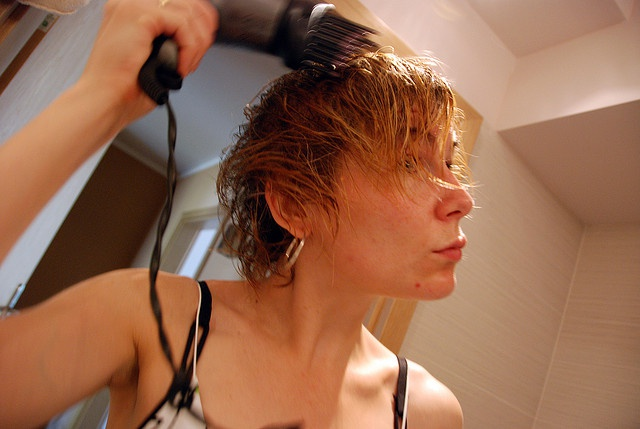Describe the objects in this image and their specific colors. I can see people in black, brown, salmon, tan, and maroon tones and hair drier in black, maroon, and gray tones in this image. 